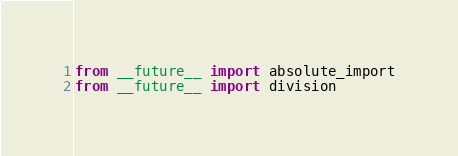Convert code to text. <code><loc_0><loc_0><loc_500><loc_500><_Python_>from __future__ import absolute_import
from __future__ import division</code> 